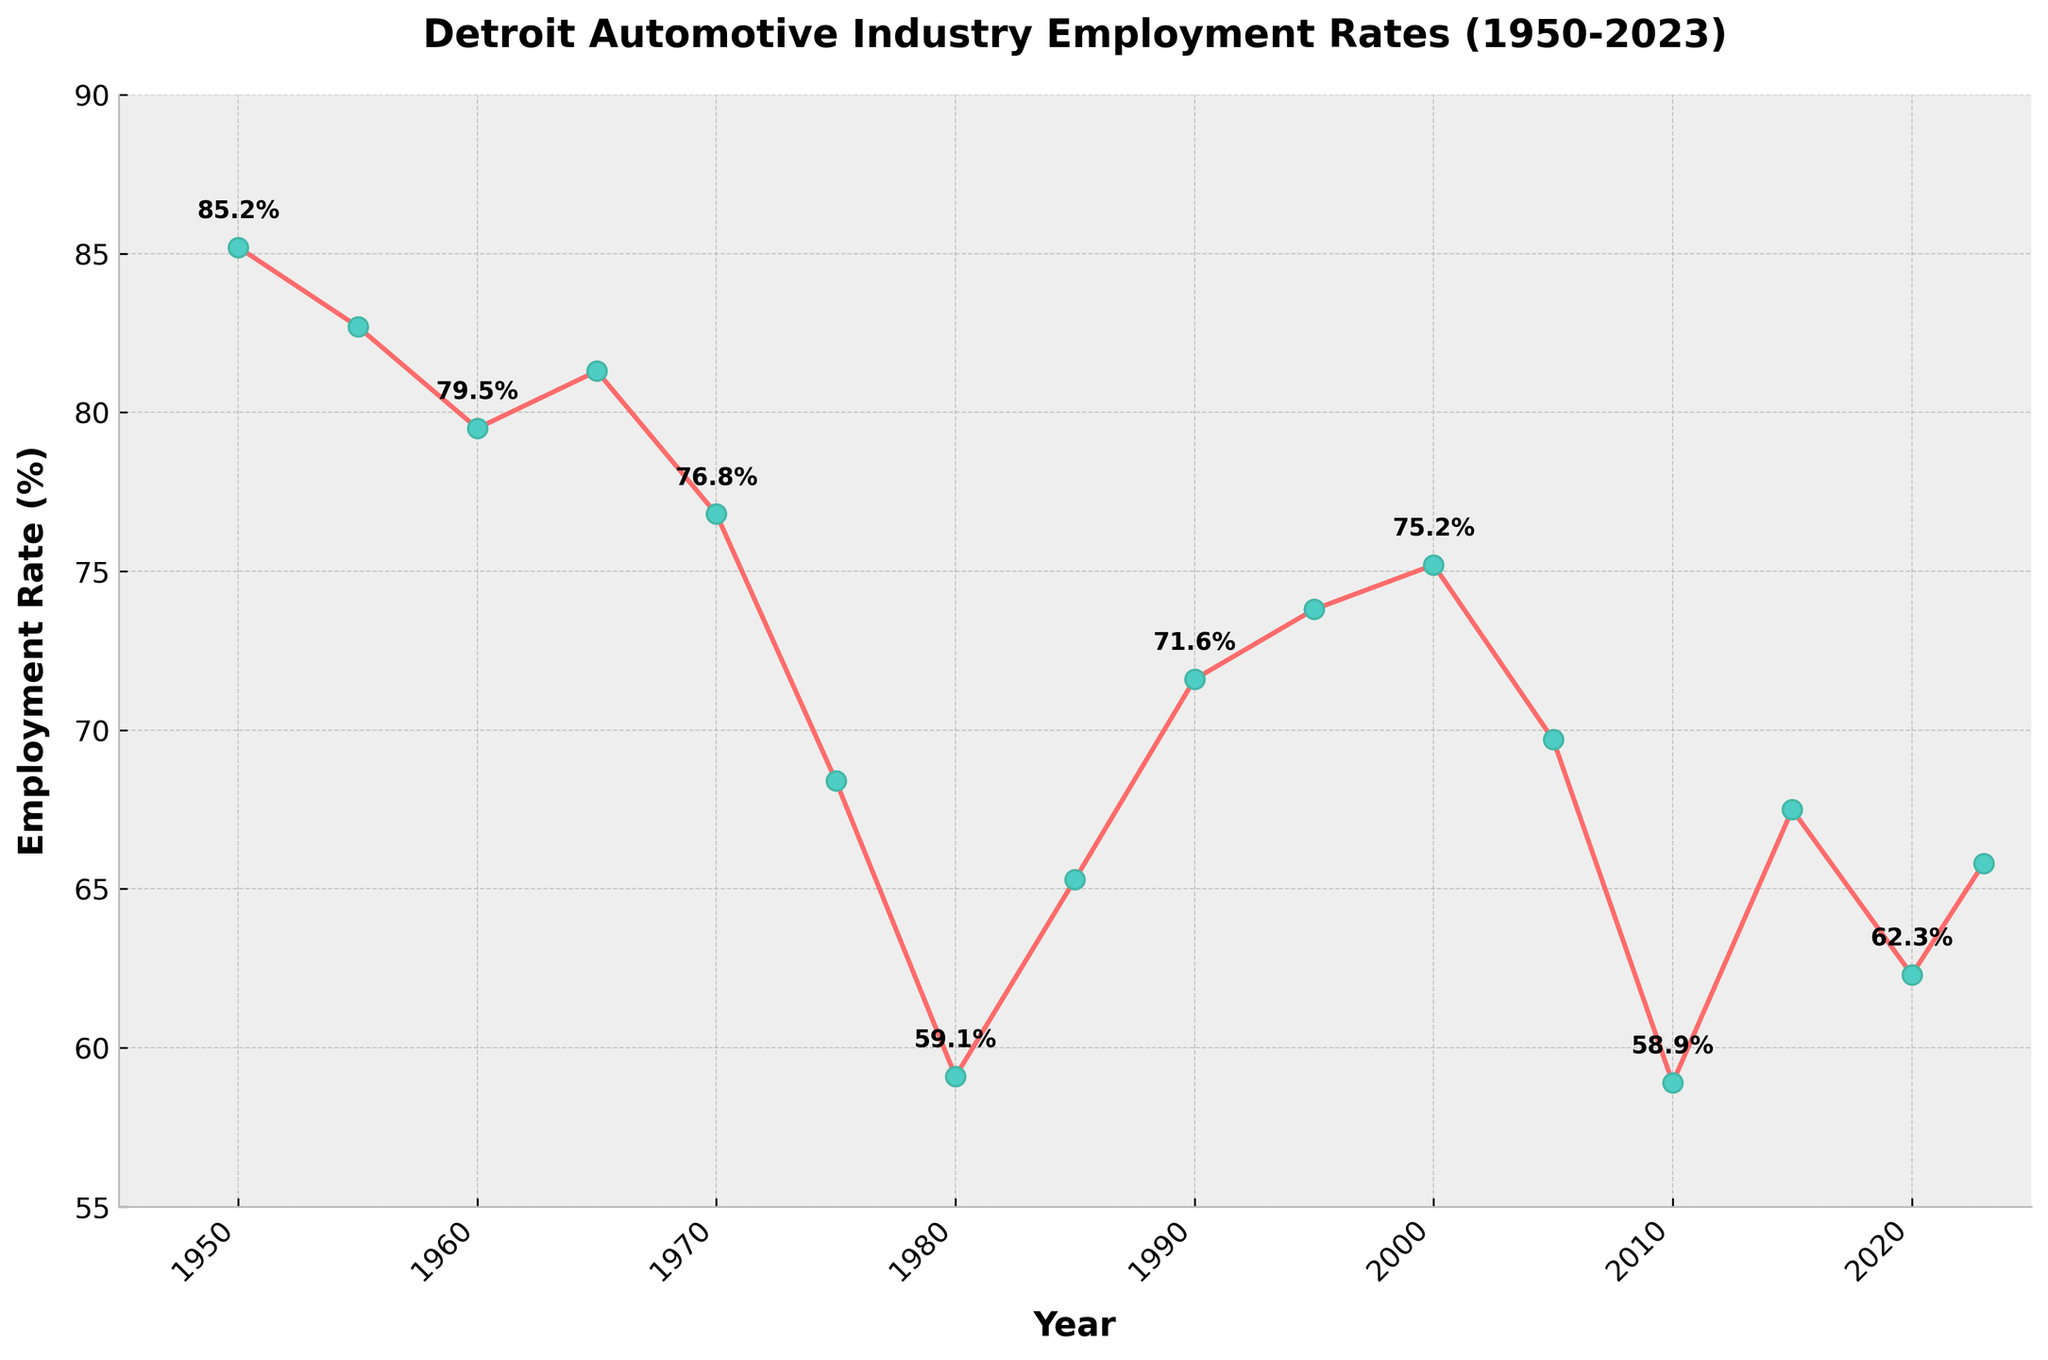Which year had the highest employment rate in the Detroit automotive industry? The highest point in the chart corresponds to 1950 with an employment rate of 85.2%.
Answer: 1950 What is the difference in the employment rate between 1980 and 1985? The employment rate in 1980 was 59.1%, and in 1985 it was 65.3%. The difference is 65.3% - 59.1% = 6.2%.
Answer: 6.2% In which years did the employment rate fall below 60%? By inspecting the chart, the employment rates fell below 60% in 1980, 2010, and 2015.
Answer: 1980, 2010, 2015 What is the average employment rate for the years 2000, 2005, 2010, 2015, and 2020? To find the average, add the employment rates for those years (75.2% + 69.7% + 58.9% + 67.5% + 62.3%) and divide by the number of years (5). The sum is 333.6%, and the average is 333.6% / 5 = 66.72%.
Answer: 66.72% How does the employment rate in 2023 compare to the rate in 2000? The employment rate in 2000 was 75.2%, and in 2023 it is 65.8%. The 2023 rate is lower by 75.2% - 65.8% = 9.4%.
Answer: 2023 rate is lower by 9.4% Which decade experienced the largest decline in employment rates? Comparing the declines: 
1950s: 85.2% to 79.5% (5.7%)
1960s: 79.5% to 76.8% (2.7%)
1970s: 76.8% to 68.4% (8.4%)
1980s: 59.1% to 65.3% (+6.2% increase)
1990s: 71.6% to 75.2% (+3.6% increase)
2000s: 75.2% to 69.7% (5.5%)
2010s: 58.9% to 67.5% (+8.6% increase)
The largest decline occurred in the 1970s with 8.4%.
Answer: 1970s What is the employment rate trend from 1985 to 2000? From 1985 to 2000, the employment rate increased from 65.3% to 75.2%. The trend is an upward one.
Answer: Upward Between which consecutive years was the sharpest drop in employment rates observed? Examining year-to-year drops:
1955-1960: 82.7% to 79.5% (3.2%)
1965-1970: 81.3% to 76.8% (4.5%)
1970-1975: 76.8% to 68.4% (8.4%)
1975-1980: 68.4% to 59.1% (9.3%)
2000-2005: 75.2% to 69.7% (5.5%)
2005-2010: 69.7% to 58.9% (10.8%)
The sharpest drop is between 2005 and 2010 (10.8%).
Answer: 2005-2010 How does the employment rate in 1990 compare to the rates in the preceding year (1985) and the subsequent year (1995)? Employment rate in 1990 was 71.6%. It increased from 65.3% in 1985 (an increase of 6.3%) and further increased to 73.8% in 1995 (an increase of 2.2%).
Answer: Increased in both preceding and subsequent years 